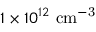<formula> <loc_0><loc_0><loc_500><loc_500>1 \times 1 0 ^ { 1 2 } \ c m ^ { - 3 }</formula> 